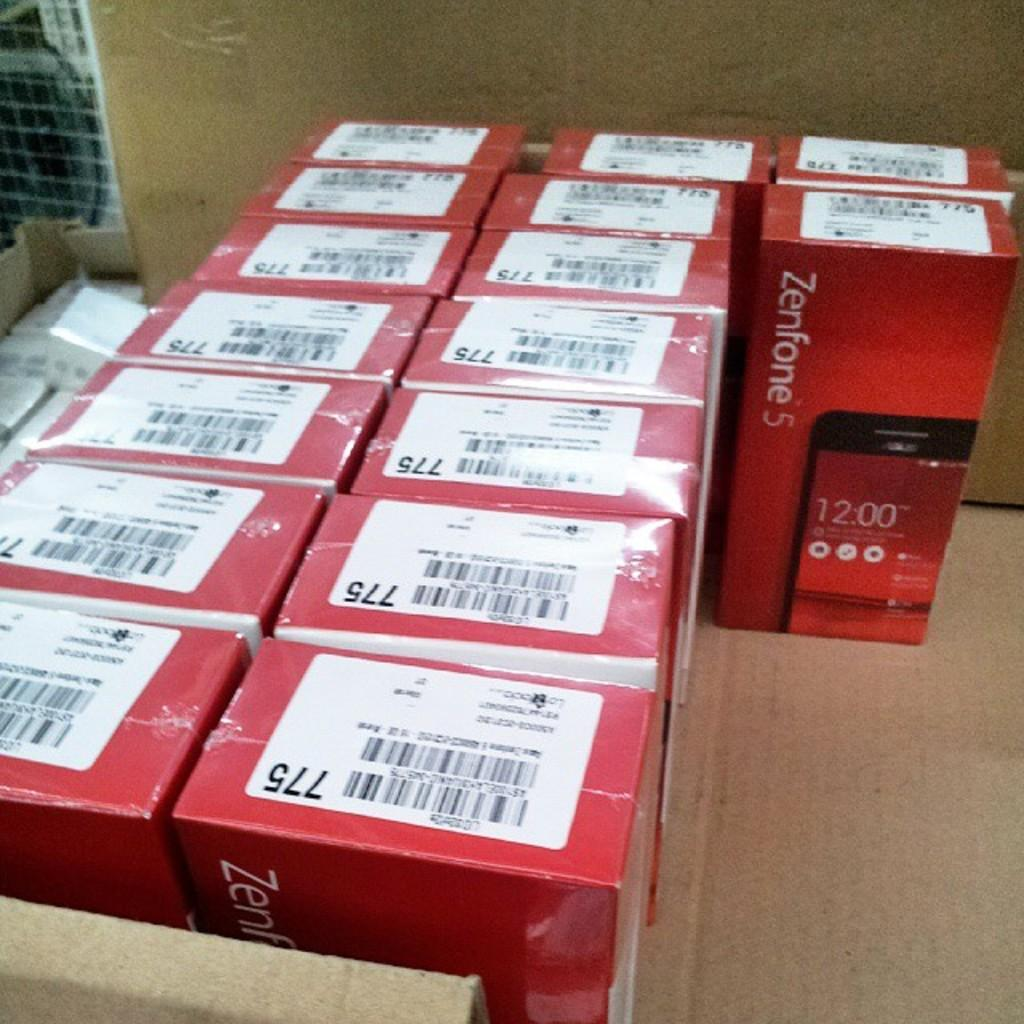Provide a one-sentence caption for the provided image. Red boxes with the name Zenfone 5 on the front packaged together. 